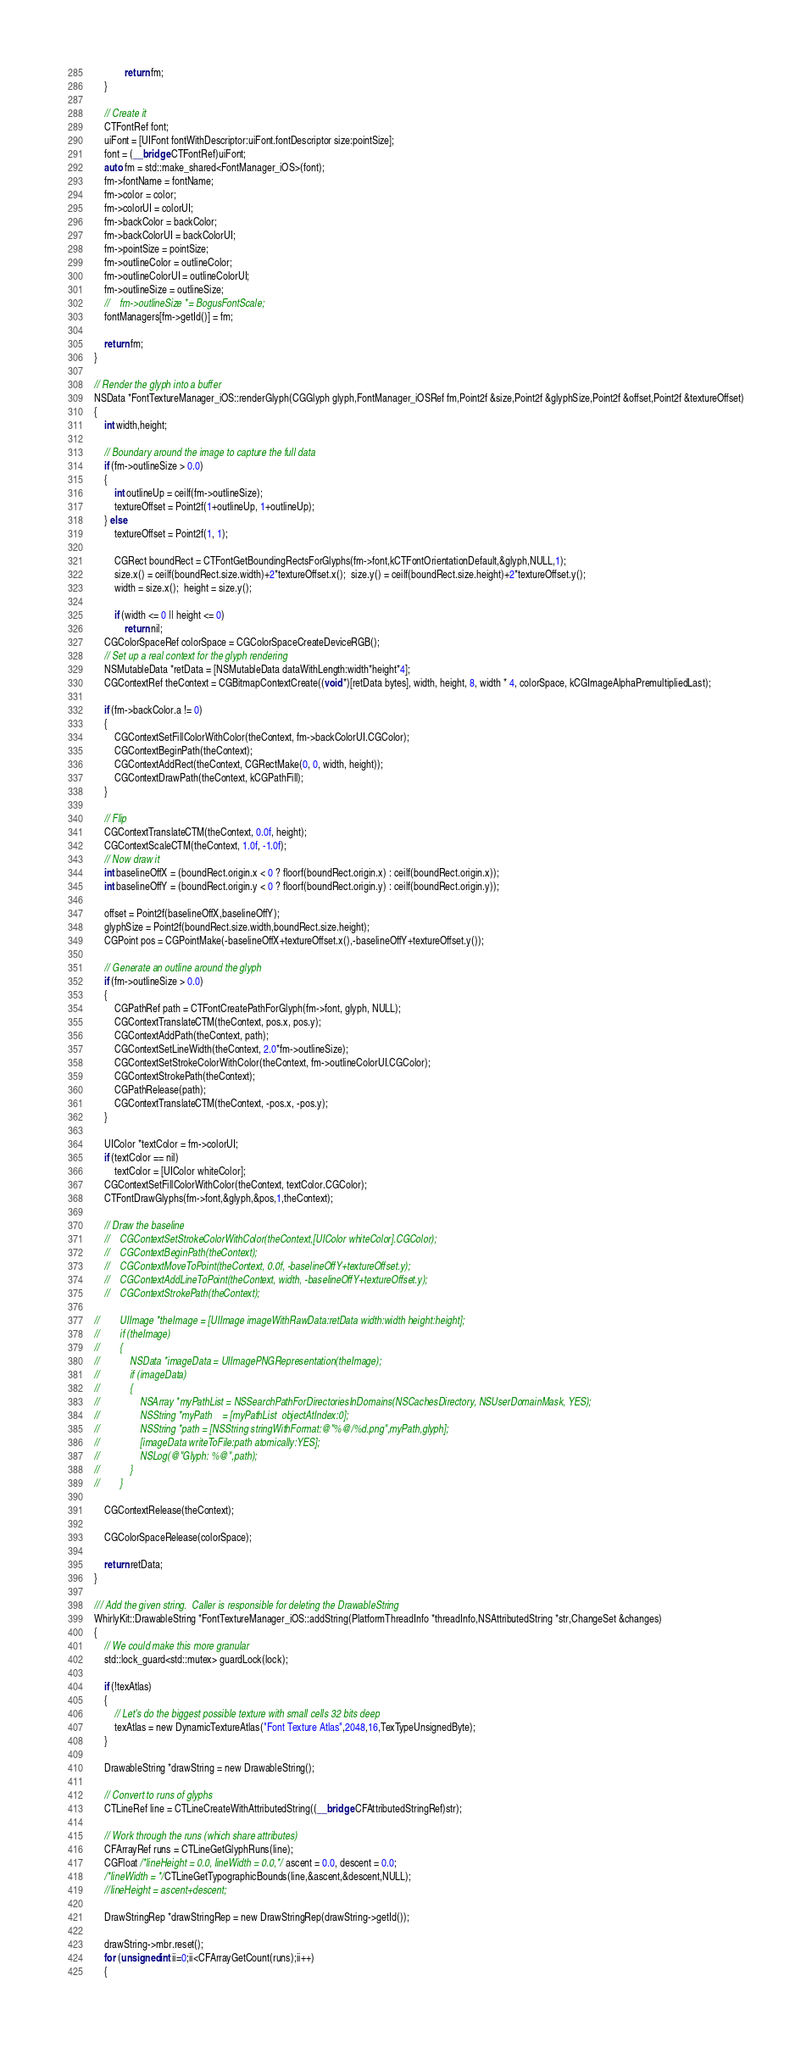<code> <loc_0><loc_0><loc_500><loc_500><_ObjectiveC_>            return fm;
    }
    
    // Create it
    CTFontRef font;
    uiFont = [UIFont fontWithDescriptor:uiFont.fontDescriptor size:pointSize];
    font = (__bridge CTFontRef)uiFont;
    auto fm = std::make_shared<FontManager_iOS>(font);
    fm->fontName = fontName;
    fm->color = color;
    fm->colorUI = colorUI;
    fm->backColor = backColor;
    fm->backColorUI = backColorUI;
    fm->pointSize = pointSize;
    fm->outlineColor = outlineColor;
    fm->outlineColorUI = outlineColorUI;
    fm->outlineSize = outlineSize;
    //    fm->outlineSize *= BogusFontScale;
    fontManagers[fm->getId()] = fm;

    return fm;
}

// Render the glyph into a buffer
NSData *FontTextureManager_iOS::renderGlyph(CGGlyph glyph,FontManager_iOSRef fm,Point2f &size,Point2f &glyphSize,Point2f &offset,Point2f &textureOffset)
{
    int width,height;
    
    // Boundary around the image to capture the full data
    if (fm->outlineSize > 0.0)
    {
        int outlineUp = ceilf(fm->outlineSize);
        textureOffset = Point2f(1+outlineUp, 1+outlineUp);
    } else
        textureOffset = Point2f(1, 1);
    
        CGRect boundRect = CTFontGetBoundingRectsForGlyphs(fm->font,kCTFontOrientationDefault,&glyph,NULL,1);
        size.x() = ceilf(boundRect.size.width)+2*textureOffset.x();  size.y() = ceilf(boundRect.size.height)+2*textureOffset.y();
        width = size.x();  height = size.y();
    
        if (width <= 0 || height <= 0)
            return nil;
    CGColorSpaceRef colorSpace = CGColorSpaceCreateDeviceRGB();
    // Set up a real context for the glyph rendering
    NSMutableData *retData = [NSMutableData dataWithLength:width*height*4];
    CGContextRef theContext = CGBitmapContextCreate((void *)[retData bytes], width, height, 8, width * 4, colorSpace, kCGImageAlphaPremultipliedLast);
    
    if (fm->backColor.a != 0)
    {
        CGContextSetFillColorWithColor(theContext, fm->backColorUI.CGColor);
        CGContextBeginPath(theContext);
        CGContextAddRect(theContext, CGRectMake(0, 0, width, height));
        CGContextDrawPath(theContext, kCGPathFill);
    }
    
    // Flip
    CGContextTranslateCTM(theContext, 0.0f, height);
    CGContextScaleCTM(theContext, 1.0f, -1.0f);
    // Now draw it
    int baselineOffX = (boundRect.origin.x < 0 ? floorf(boundRect.origin.x) : ceilf(boundRect.origin.x));
    int baselineOffY = (boundRect.origin.y < 0 ? floorf(boundRect.origin.y) : ceilf(boundRect.origin.y));
    
    offset = Point2f(baselineOffX,baselineOffY);
    glyphSize = Point2f(boundRect.size.width,boundRect.size.height);
    CGPoint pos = CGPointMake(-baselineOffX+textureOffset.x(),-baselineOffY+textureOffset.y());
    
    // Generate an outline around the glyph
    if (fm->outlineSize > 0.0)
    {
        CGPathRef path = CTFontCreatePathForGlyph(fm->font, glyph, NULL);
        CGContextTranslateCTM(theContext, pos.x, pos.y);
        CGContextAddPath(theContext, path);
        CGContextSetLineWidth(theContext, 2.0*fm->outlineSize);
        CGContextSetStrokeColorWithColor(theContext, fm->outlineColorUI.CGColor);
        CGContextStrokePath(theContext);
        CGPathRelease(path);
        CGContextTranslateCTM(theContext, -pos.x, -pos.y);
    }
    
    UIColor *textColor = fm->colorUI;
    if (textColor == nil)
        textColor = [UIColor whiteColor];
    CGContextSetFillColorWithColor(theContext, textColor.CGColor);
    CTFontDrawGlyphs(fm->font,&glyph,&pos,1,theContext);

    // Draw the baseline
    //    CGContextSetStrokeColorWithColor(theContext,[UIColor whiteColor].CGColor);
    //    CGContextBeginPath(theContext);
    //    CGContextMoveToPoint(theContext, 0.0f, -baselineOffY+textureOffset.y);
    //    CGContextAddLineToPoint(theContext, width, -baselineOffY+textureOffset.y);
    //    CGContextStrokePath(theContext);

//        UIImage *theImage = [UIImage imageWithRawData:retData width:width height:height];
//        if (theImage)
//        {
//            NSData *imageData = UIImagePNGRepresentation(theImage);
//            if (imageData)
//            {
//                NSArray *myPathList = NSSearchPathForDirectoriesInDomains(NSCachesDirectory, NSUserDomainMask, YES);
//                NSString *myPath    = [myPathList  objectAtIndex:0];
//                NSString *path = [NSString stringWithFormat:@"%@/%d.png",myPath,glyph];
//                [imageData writeToFile:path atomically:YES];
//                NSLog(@"Glyph: %@",path);
//            }
//        }

    CGContextRelease(theContext);

    CGColorSpaceRelease(colorSpace);

    return retData;
}

/// Add the given string.  Caller is responsible for deleting the DrawableString
WhirlyKit::DrawableString *FontTextureManager_iOS::addString(PlatformThreadInfo *threadInfo,NSAttributedString *str,ChangeSet &changes)
{
    // We could make this more granular
    std::lock_guard<std::mutex> guardLock(lock);
    
    if (!texAtlas)
    {
        // Let's do the biggest possible texture with small cells 32 bits deep
        texAtlas = new DynamicTextureAtlas("Font Texture Atlas",2048,16,TexTypeUnsignedByte);
    }
    
    DrawableString *drawString = new DrawableString();
    
    // Convert to runs of glyphs
    CTLineRef line = CTLineCreateWithAttributedString((__bridge CFAttributedStringRef)str);
    
    // Work through the runs (which share attributes)
    CFArrayRef runs = CTLineGetGlyphRuns(line);
    CGFloat /*lineHeight = 0.0, lineWidth = 0.0,*/ ascent = 0.0, descent = 0.0;
    /*lineWidth = */CTLineGetTypographicBounds(line,&ascent,&descent,NULL);
    //lineHeight = ascent+descent;
    
    DrawStringRep *drawStringRep = new DrawStringRep(drawString->getId());
    
    drawString->mbr.reset();
    for (unsigned int ii=0;ii<CFArrayGetCount(runs);ii++)
    {</code> 